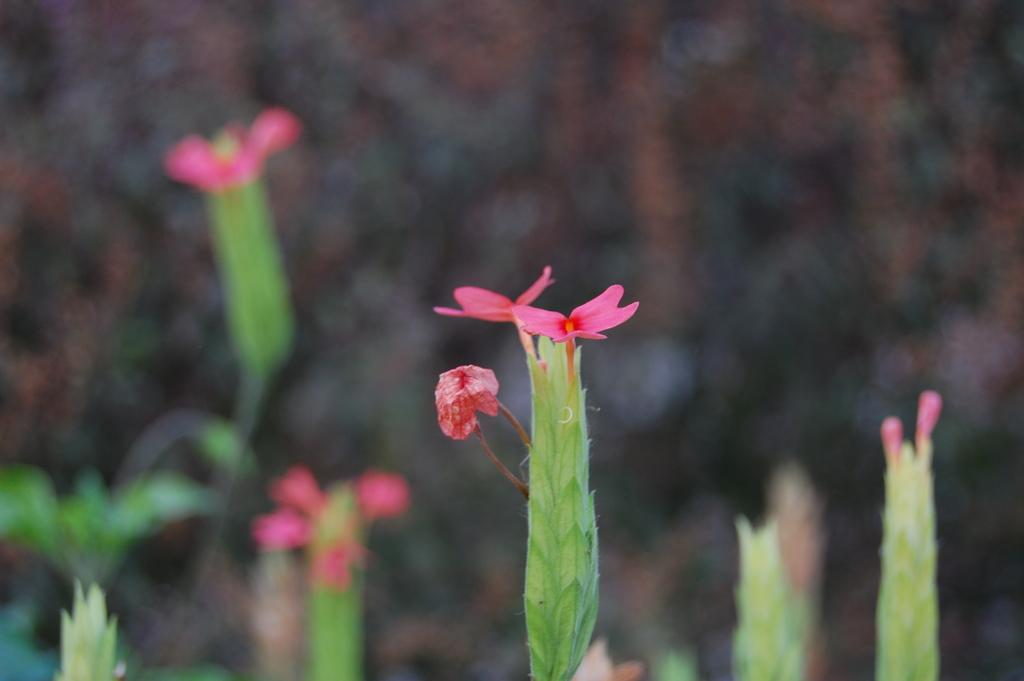What type of living organisms can be seen in the image? There are flowers in the image. What color are the flowers in the image? The flowers are pink in color. Can you tell me how many clams are visible among the flowers in the image? There are no clams present among the flowers in the image. Is there a watch visible on any of the flowers in the image? There is no watch visible on any of the flowers in the image. 